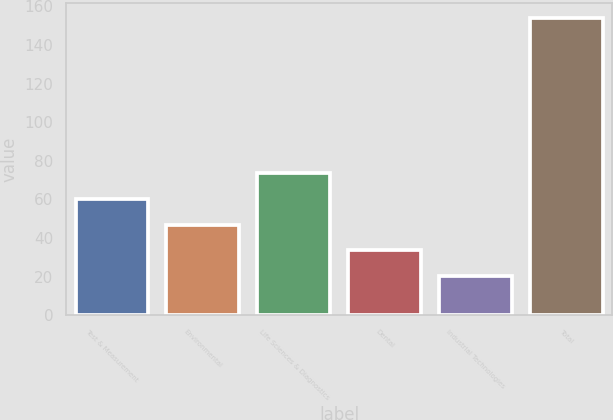Convert chart. <chart><loc_0><loc_0><loc_500><loc_500><bar_chart><fcel>Test & Measurement<fcel>Environmental<fcel>Life Sciences & Diagnostics<fcel>Dental<fcel>Industrial Technologies<fcel>Total<nl><fcel>60.37<fcel>46.98<fcel>73.76<fcel>33.59<fcel>20.2<fcel>154.1<nl></chart> 